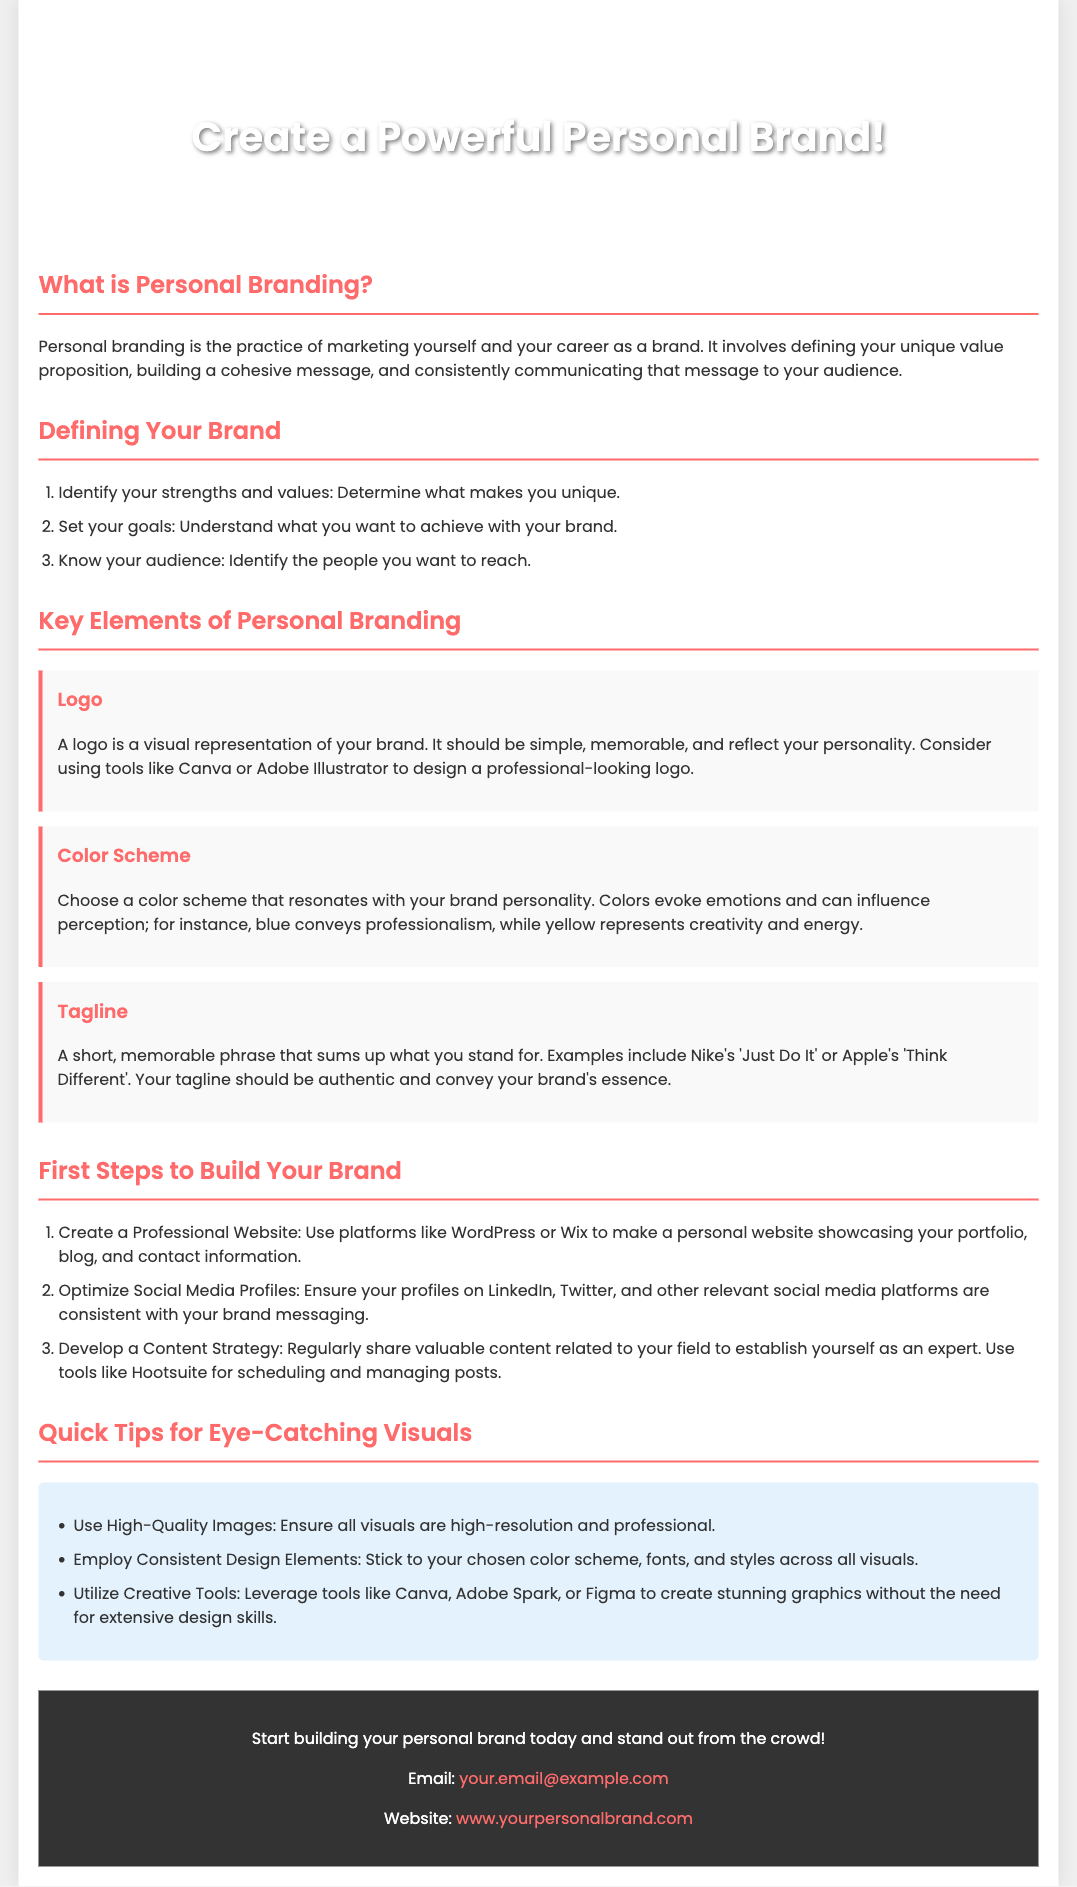What is the title of the flyer? The title is the main heading that represents the content of the flyer.
Answer: Introduction to Personal Branding: Elements and Essentials What is the color of the header text? The color of the header text is important for visual contrast and aesthetic appeal.
Answer: White How many key elements of personal branding are mentioned in the document? The number of key elements gives insight into the focus of the content.
Answer: Three Which branding tool is suggested for creating a logo? The mention of a specific tool indicates helpful resources for the reader.
Answer: Canva What type of content strategy is recommended? The content strategy outlines what actions to take in branding, illustrating the approach to audience engagement.
Answer: Share valuable content Name one emotion associated with the color blue in personal branding. Understanding the emotional impact of colors is critical in branding decisions.
Answer: Professionalism What should you create to showcase your portfolio? This question pertains to actionable advice given in the flyer regarding personal branding.
Answer: Professional Website What is one benefit of high-quality images according to the flyer? This refers to the importance of visuals in attracting attention and conveying professionalism.
Answer: Ensure all visuals are high-resolution What is the email address provided for contact? The email address serves as a direct line of communication for the audience.
Answer: your.email@example.com 